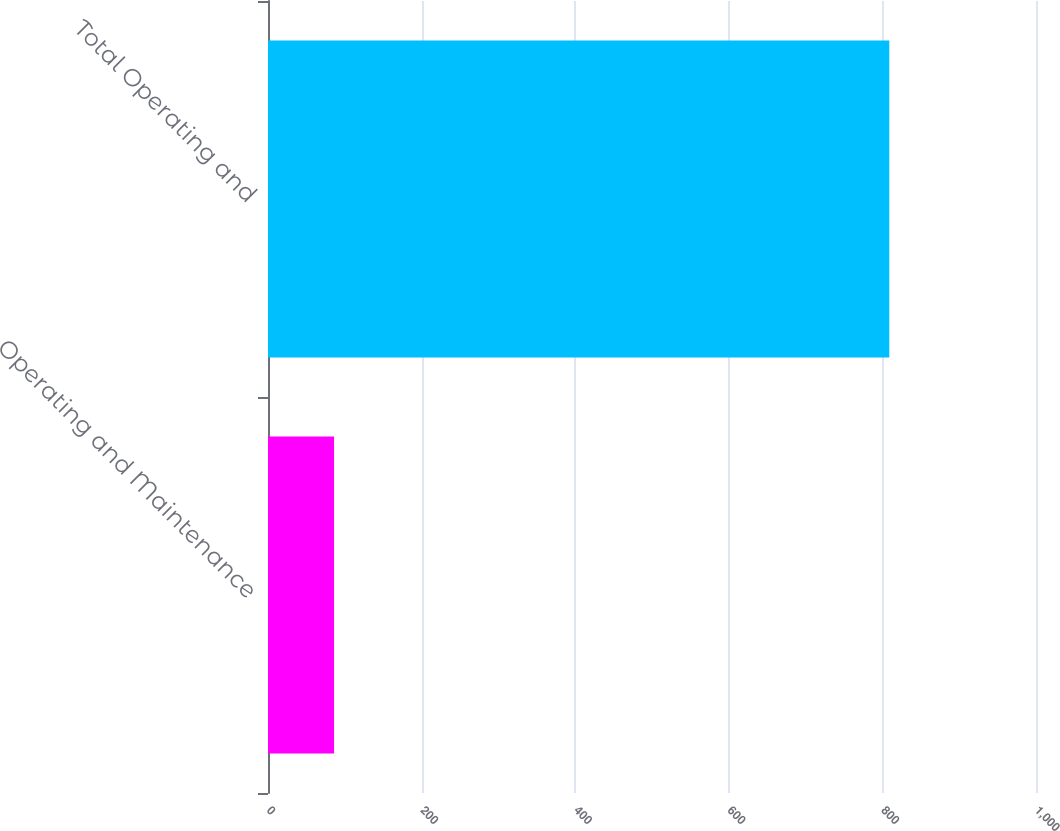<chart> <loc_0><loc_0><loc_500><loc_500><bar_chart><fcel>Operating and Maintenance<fcel>Total Operating and<nl><fcel>86<fcel>809<nl></chart> 